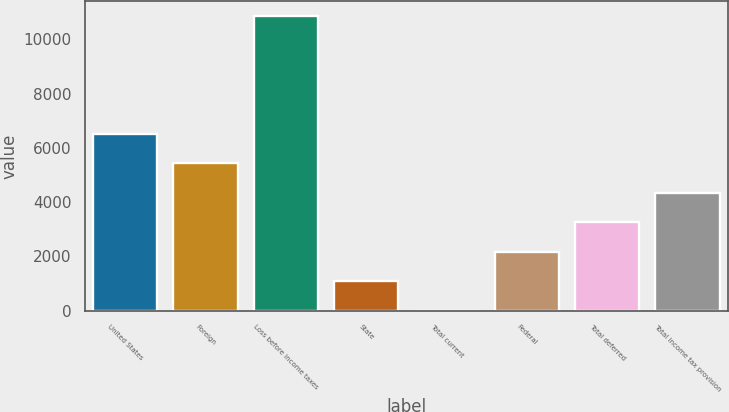Convert chart to OTSL. <chart><loc_0><loc_0><loc_500><loc_500><bar_chart><fcel>United States<fcel>Foreign<fcel>Loss before income taxes<fcel>State<fcel>Total current<fcel>Federal<fcel>Total deferred<fcel>Total income tax provision<nl><fcel>6522<fcel>5433<fcel>10863<fcel>1089<fcel>3<fcel>2175<fcel>3261<fcel>4347<nl></chart> 